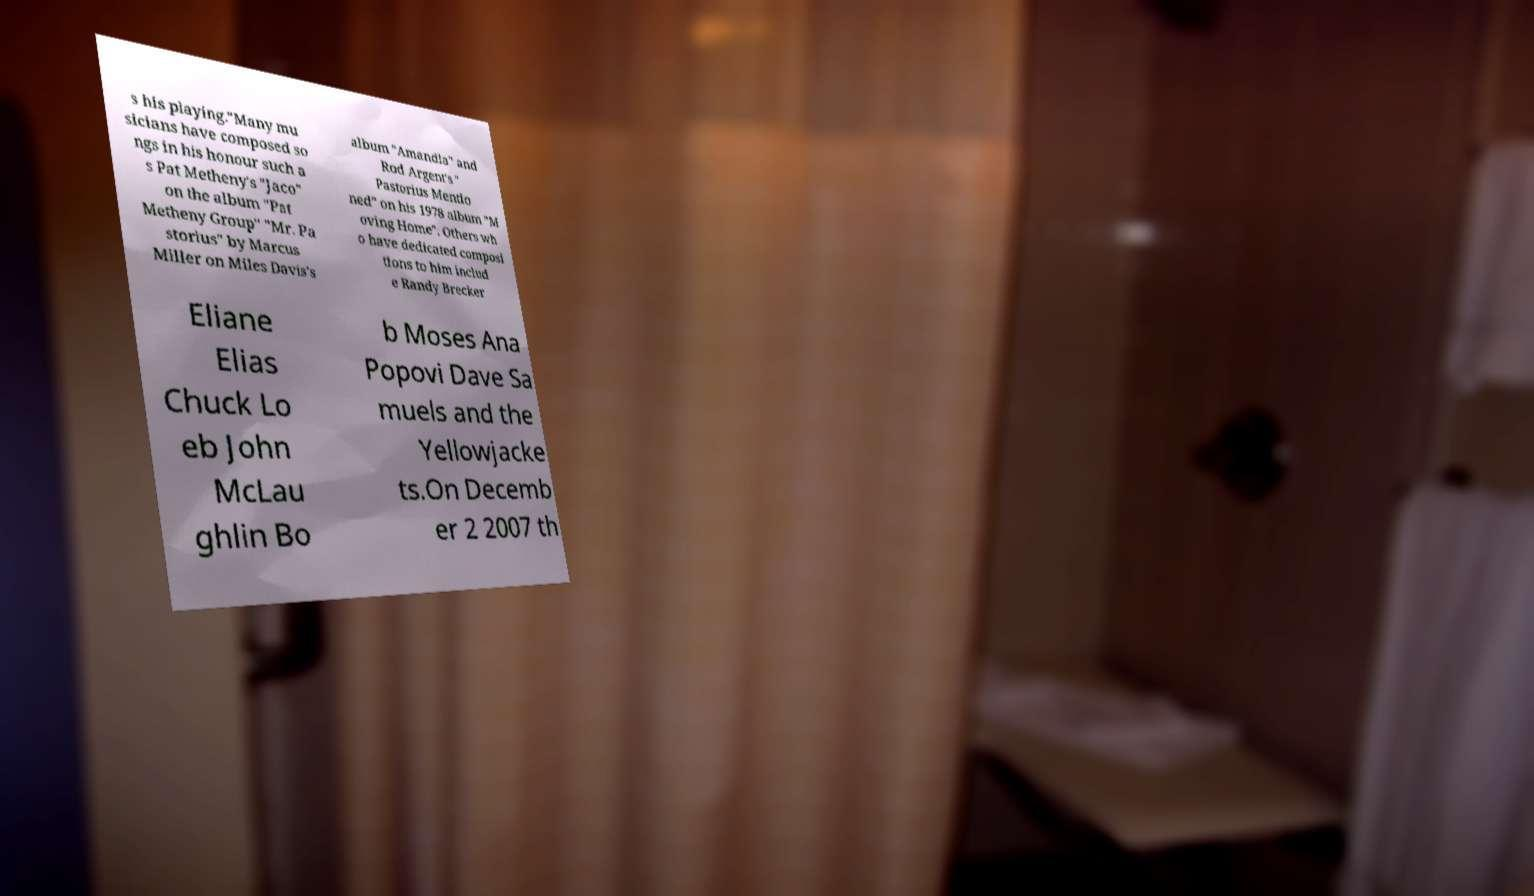What messages or text are displayed in this image? I need them in a readable, typed format. s his playing."Many mu sicians have composed so ngs in his honour such a s Pat Metheny's "Jaco" on the album "Pat Metheny Group" "Mr. Pa storius" by Marcus Miller on Miles Davis's album "Amandla" and Rod Argent's " Pastorius Mentio ned" on his 1978 album "M oving Home". Others wh o have dedicated composi tions to him includ e Randy Brecker Eliane Elias Chuck Lo eb John McLau ghlin Bo b Moses Ana Popovi Dave Sa muels and the Yellowjacke ts.On Decemb er 2 2007 th 